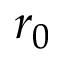<formula> <loc_0><loc_0><loc_500><loc_500>r _ { 0 }</formula> 